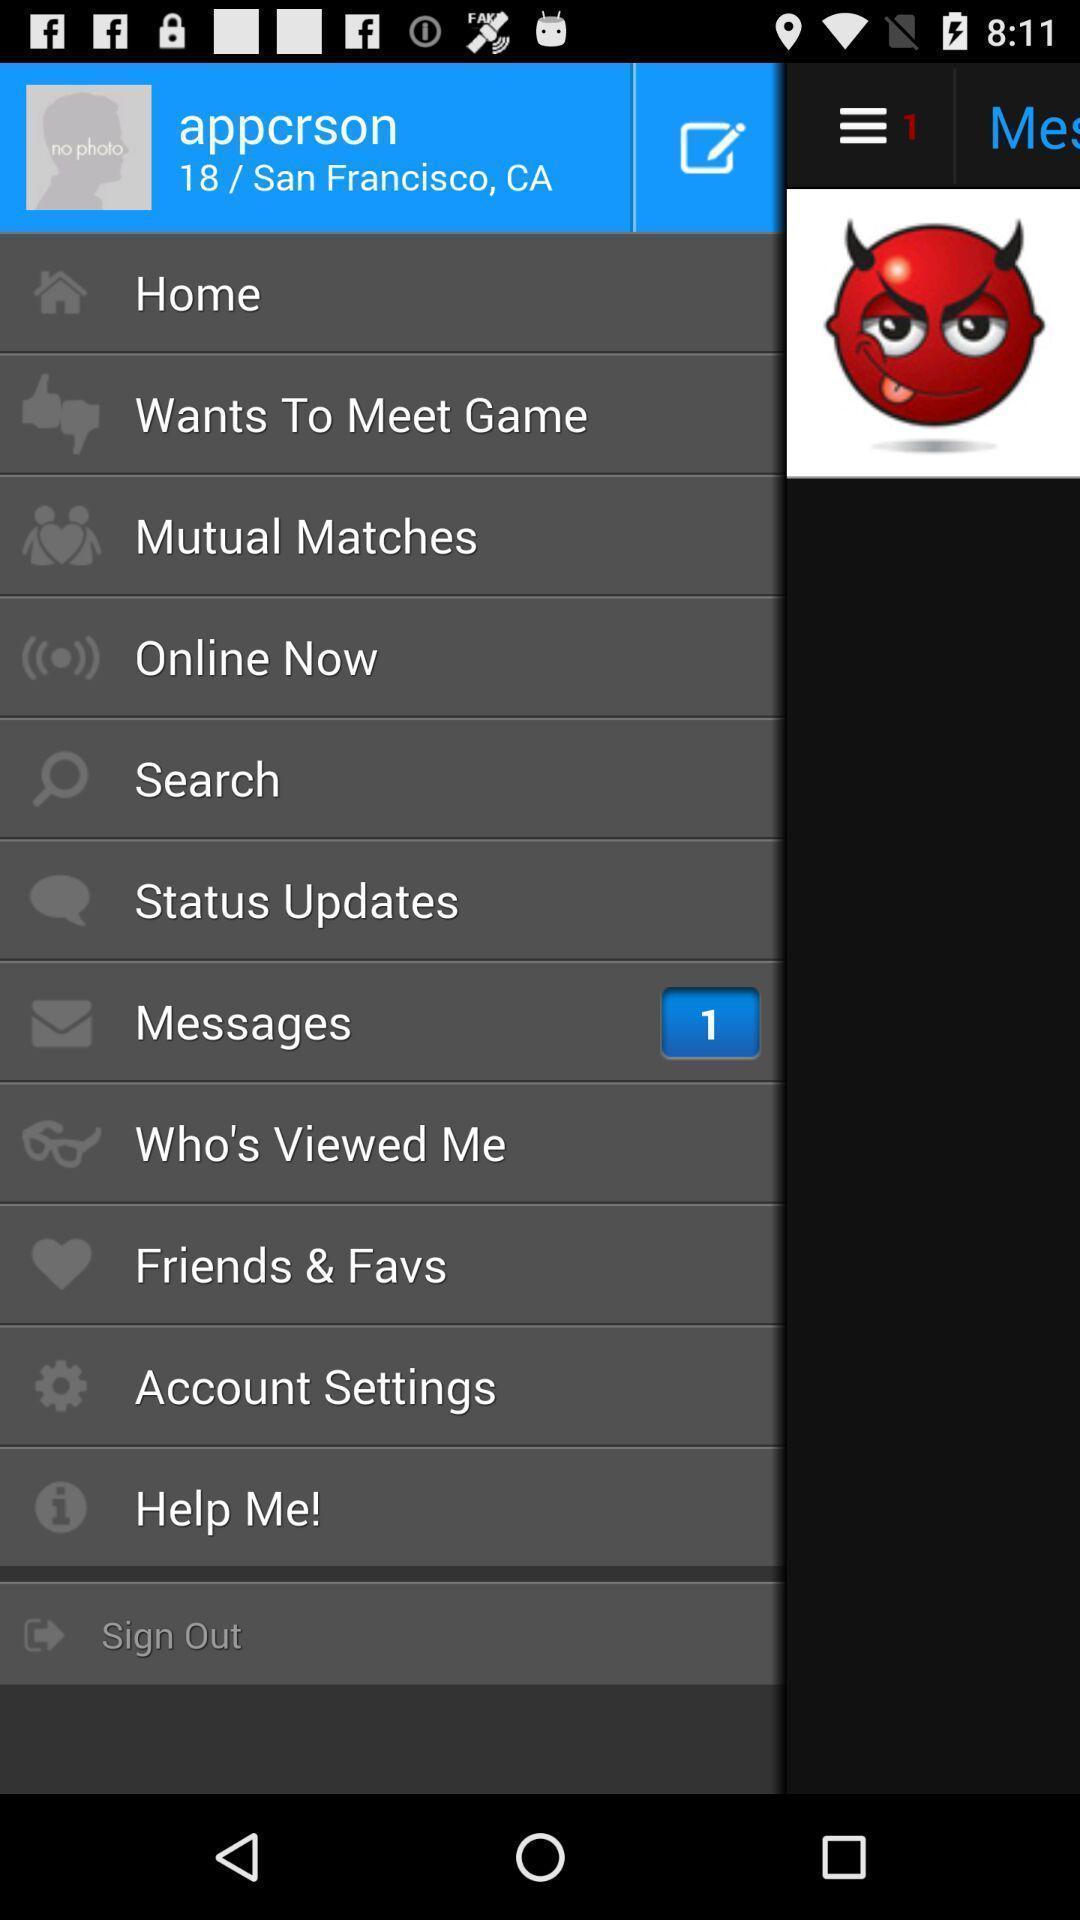Give me a summary of this screen capture. Pop-up showing different kinds of options. 